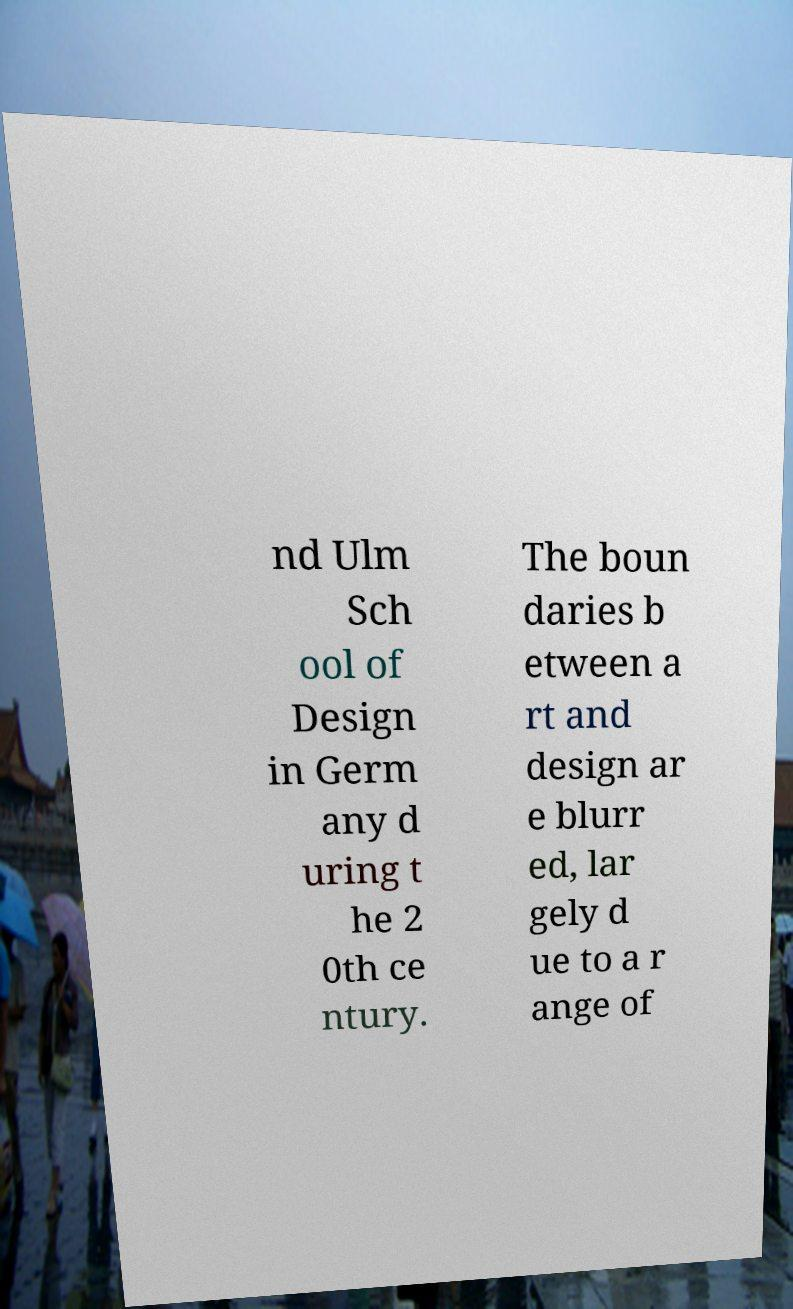For documentation purposes, I need the text within this image transcribed. Could you provide that? nd Ulm Sch ool of Design in Germ any d uring t he 2 0th ce ntury. The boun daries b etween a rt and design ar e blurr ed, lar gely d ue to a r ange of 